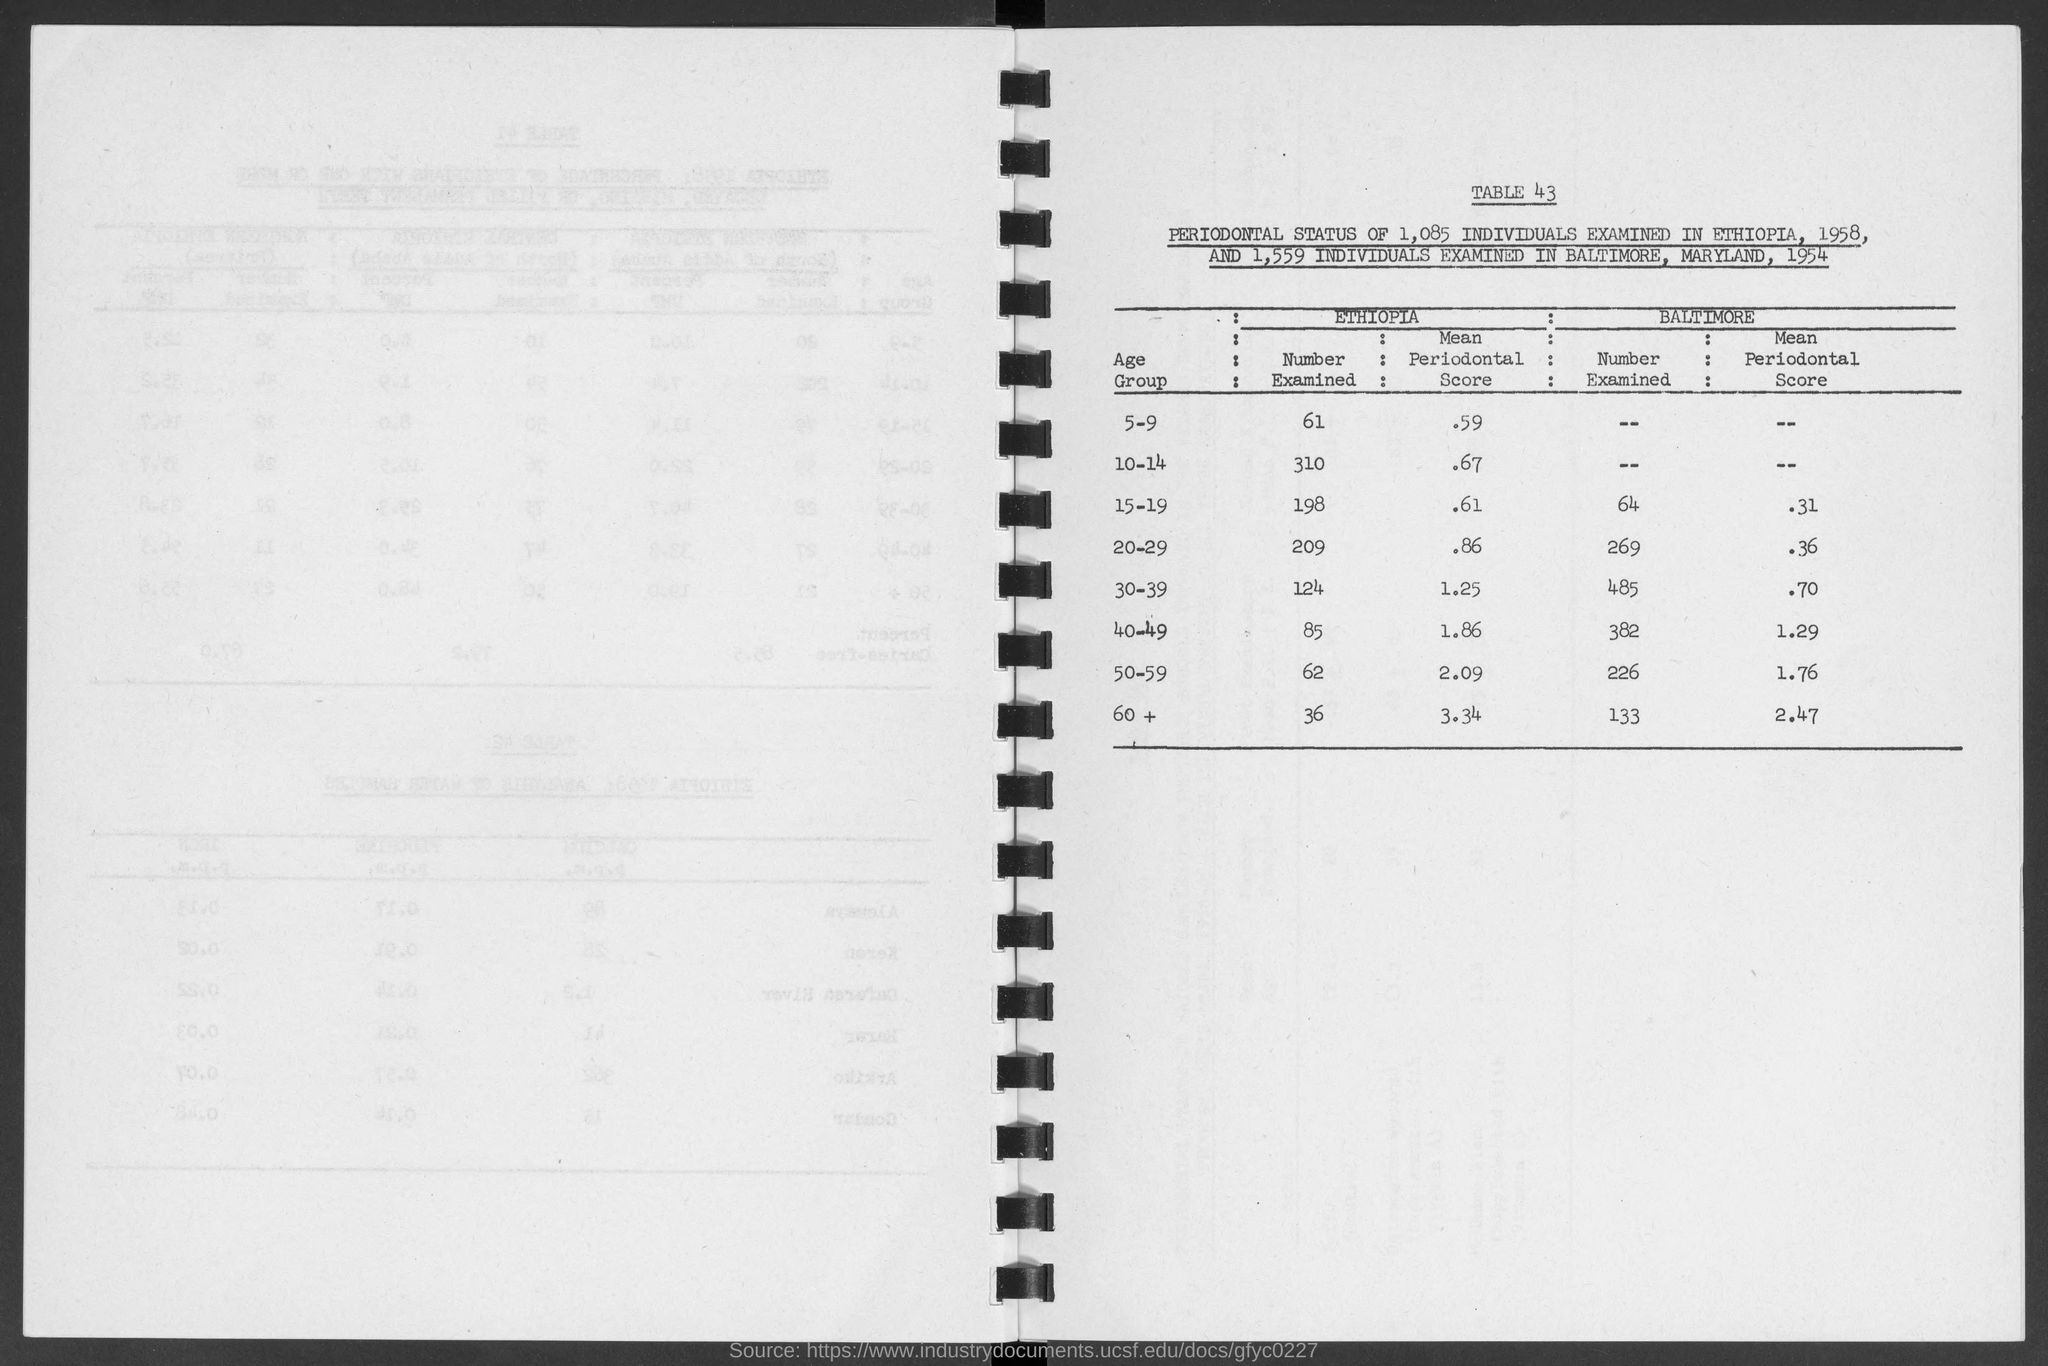What is the table no.?
Offer a terse response. 43. What is the number examined in ethiopia for age group of 5-9?
Offer a very short reply. 61. What is the number examined in ethiopia for age group of 10-14?
Offer a terse response. 310. What is the number examined in ethiopia for age group of 15-19?
Keep it short and to the point. 198. What is the number examined in ethiopia for age group of 20-29?
Offer a very short reply. 209. What is the number examined in ethiopia for age group of 30-39?
Keep it short and to the point. 124. What is the number examined in ethiopia for age group of 40-49?
Your answer should be compact. 85. What is the number examined in ethiopia for age group of 50-59?
Make the answer very short. 62. What is the number examined in ethiopia for age group of +60?
Offer a very short reply. 36. What is the number examined in baltimore for age group of 15-19?
Give a very brief answer. 64. 